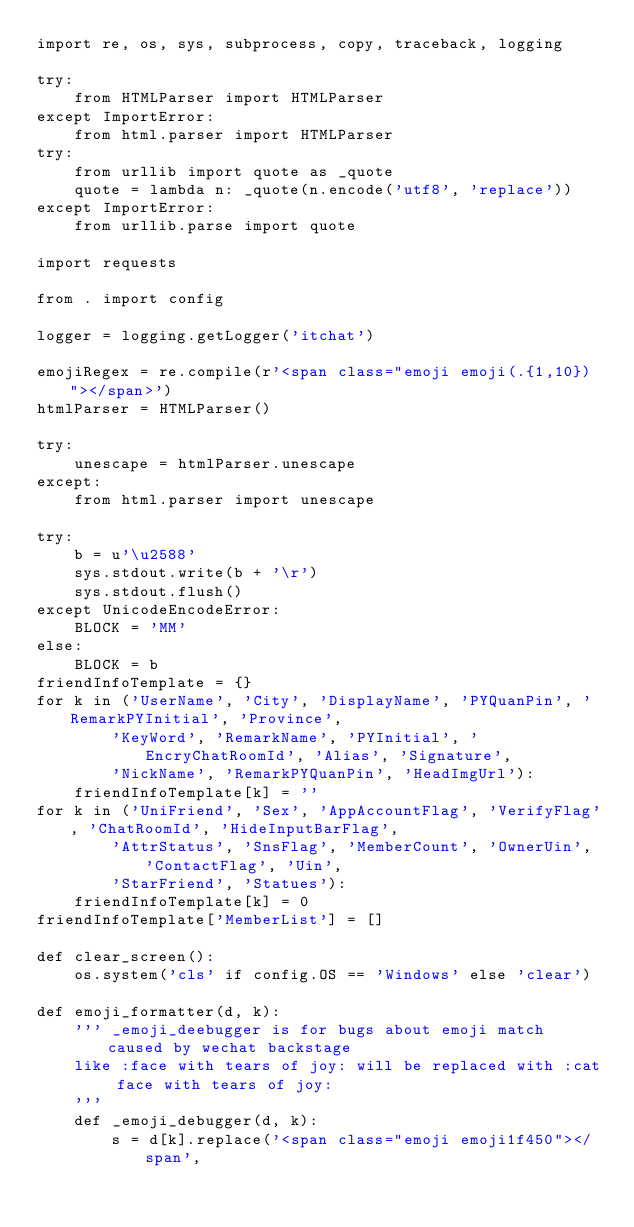<code> <loc_0><loc_0><loc_500><loc_500><_Python_>import re, os, sys, subprocess, copy, traceback, logging

try:
    from HTMLParser import HTMLParser
except ImportError:
    from html.parser import HTMLParser
try:
    from urllib import quote as _quote
    quote = lambda n: _quote(n.encode('utf8', 'replace'))
except ImportError:
    from urllib.parse import quote

import requests

from . import config

logger = logging.getLogger('itchat')

emojiRegex = re.compile(r'<span class="emoji emoji(.{1,10})"></span>')
htmlParser = HTMLParser()

try:
    unescape = htmlParser.unescape
except:
    from html.parser import unescape

try:
    b = u'\u2588'
    sys.stdout.write(b + '\r')
    sys.stdout.flush()
except UnicodeEncodeError:
    BLOCK = 'MM'
else:
    BLOCK = b
friendInfoTemplate = {}
for k in ('UserName', 'City', 'DisplayName', 'PYQuanPin', 'RemarkPYInitial', 'Province',
        'KeyWord', 'RemarkName', 'PYInitial', 'EncryChatRoomId', 'Alias', 'Signature',
        'NickName', 'RemarkPYQuanPin', 'HeadImgUrl'):
    friendInfoTemplate[k] = ''
for k in ('UniFriend', 'Sex', 'AppAccountFlag', 'VerifyFlag', 'ChatRoomId', 'HideInputBarFlag',
        'AttrStatus', 'SnsFlag', 'MemberCount', 'OwnerUin', 'ContactFlag', 'Uin',
        'StarFriend', 'Statues'):
    friendInfoTemplate[k] = 0
friendInfoTemplate['MemberList'] = []

def clear_screen():
    os.system('cls' if config.OS == 'Windows' else 'clear')

def emoji_formatter(d, k):
    ''' _emoji_deebugger is for bugs about emoji match caused by wechat backstage
    like :face with tears of joy: will be replaced with :cat face with tears of joy:
    '''
    def _emoji_debugger(d, k):
        s = d[k].replace('<span class="emoji emoji1f450"></span',</code> 